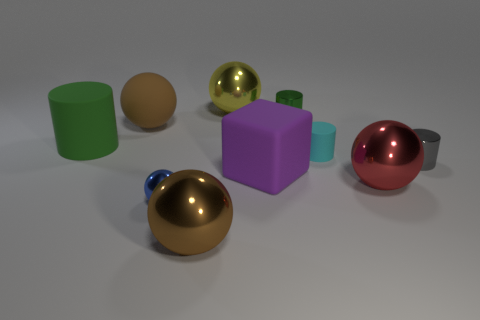Subtract all big rubber balls. How many balls are left? 4 Subtract all gray cubes. How many green cylinders are left? 2 Subtract all cyan cylinders. How many cylinders are left? 3 Subtract all blocks. How many objects are left? 9 Subtract all blue balls. Subtract all brown cylinders. How many balls are left? 4 Subtract all gray shiny objects. Subtract all large metallic objects. How many objects are left? 6 Add 7 brown matte objects. How many brown matte objects are left? 8 Add 3 yellow metallic objects. How many yellow metallic objects exist? 4 Subtract 0 red blocks. How many objects are left? 10 Subtract 2 cylinders. How many cylinders are left? 2 